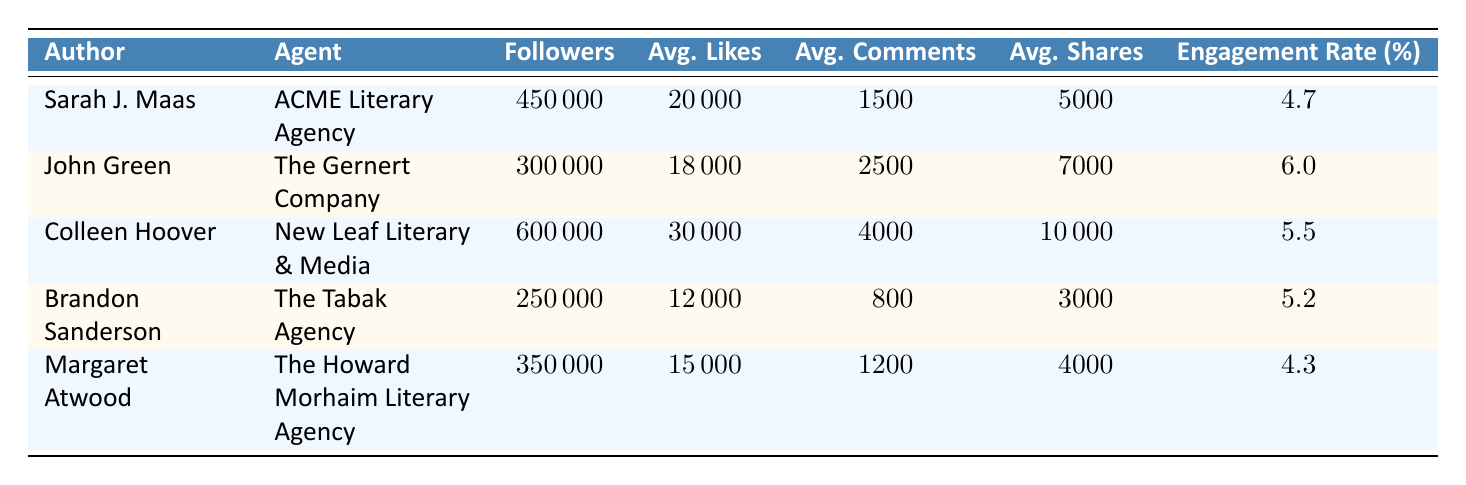What's the total number of followers for all the authors listed? To find the total number of followers, we sum the followers of each author: 450000 (Sarah J. Maas) + 300000 (John Green) + 600000 (Colleen Hoover) + 250000 (Brandon Sanderson) + 350000 (Margaret Atwood) = 1950000
Answer: 1950000 Which author has the highest average likes per post? Comparing the average likes per post for each author: Sarah J. Maas (20000), John Green (18000), Colleen Hoover (30000), Brandon Sanderson (12000), and Margaret Atwood (15000). Colleen Hoover has the highest average likes per post at 30000.
Answer: Colleen Hoover What is the engagement rate of John Green? The engagement rate for John Green is provided directly in the table as 6.0%.
Answer: 6.0 Is it true that Brandon Sanderson has more average comments per post than Sarah J. Maas? Checking the average comments: Brandon Sanderson has 800 average comments per post, while Sarah J. Maas has 1500. Since 800 is less than 1500, this statement is false.
Answer: No What is the average number of shares per post for authors with the highest engagement rate? The author with the highest engagement rate is John Green (6.0%) and Colleen Hoover (5.5%). John Green has an average of 7000 shares per post, and Colleen Hoover has 10000 shares per post. The average of these two values is (7000 + 10000) / 2 = 13500 / 2 = 6750.
Answer: 6750 Who has the lowest engagement rate, and what is it? Looking through engagement rates, Sarah J. Maas has 4.7%, John Green has 6.0%, Colleen Hoover has 5.5%, Brandon Sanderson has 5.2%, and Margaret Atwood has 4.3%. Margaret Atwood has the lowest engagement rate.
Answer: Margaret Atwood, 4.3 How many authors have an engagement rate greater than or equal to 5%? The engagement rates are: Sarah J. Maas (4.7%), John Green (6.0%), Colleen Hoover (5.5%), Brandon Sanderson (5.2%), and Margaret Atwood (4.3%). Three authors (John Green, Colleen Hoover, Brandon Sanderson) have engagement rates of 5% or greater.
Answer: 3 What is the difference in average comments per post between Colleen Hoover and Margaret Atwood? Colleen Hoover has 4000 average comments per post, while Margaret Atwood has 1200. The difference is 4000 - 1200 = 2800.
Answer: 2800 What was the total average likes per post for authors represented by ACME Literary Agency and New Leaf Literary & Media? The average likes per post for Sarah J. Maas (20000) and Colleen Hoover (30000) are summed: 20000 + 30000 = 50000.
Answer: 50000 